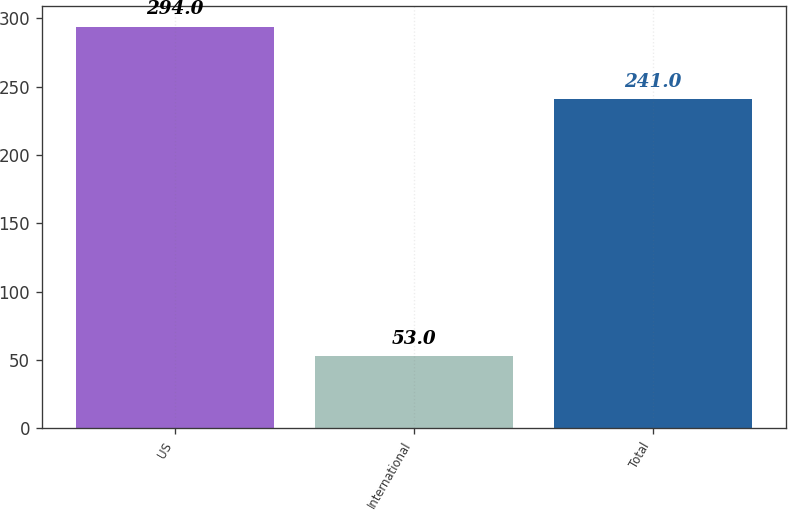Convert chart to OTSL. <chart><loc_0><loc_0><loc_500><loc_500><bar_chart><fcel>US<fcel>International<fcel>Total<nl><fcel>294<fcel>53<fcel>241<nl></chart> 